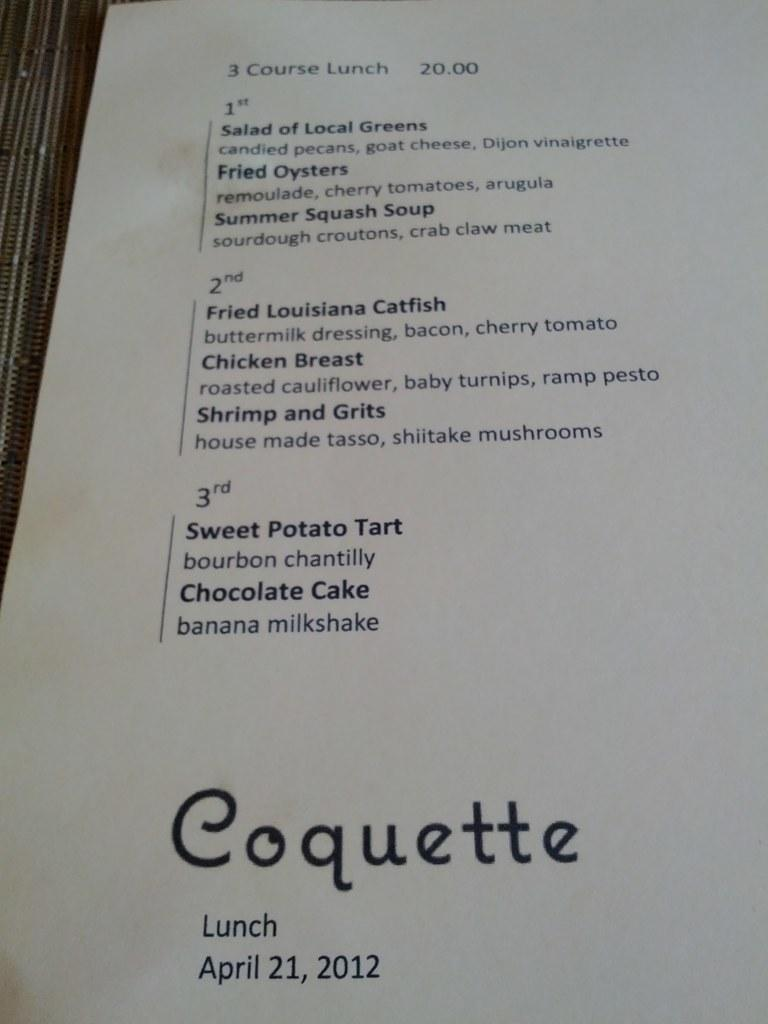Provide a one-sentence caption for the provided image. The pamphlet explained the 3 courses of lunch they offered at $20.00. 